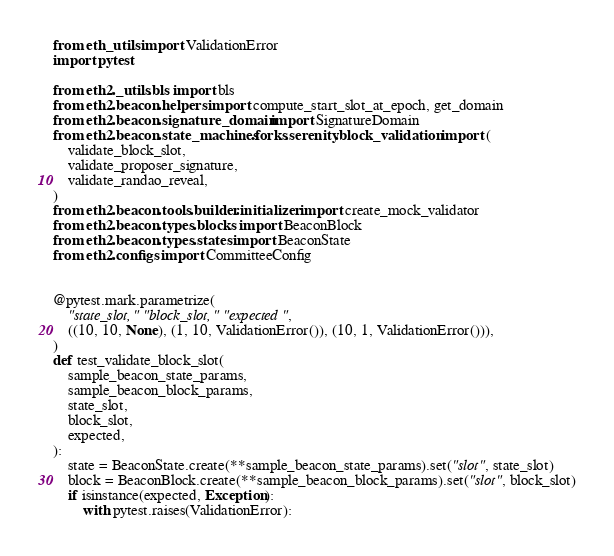<code> <loc_0><loc_0><loc_500><loc_500><_Python_>from eth_utils import ValidationError
import pytest

from eth2._utils.bls import bls
from eth2.beacon.helpers import compute_start_slot_at_epoch, get_domain
from eth2.beacon.signature_domain import SignatureDomain
from eth2.beacon.state_machines.forks.serenity.block_validation import (
    validate_block_slot,
    validate_proposer_signature,
    validate_randao_reveal,
)
from eth2.beacon.tools.builder.initializer import create_mock_validator
from eth2.beacon.types.blocks import BeaconBlock
from eth2.beacon.types.states import BeaconState
from eth2.configs import CommitteeConfig


@pytest.mark.parametrize(
    "state_slot," "block_slot," "expected",
    ((10, 10, None), (1, 10, ValidationError()), (10, 1, ValidationError())),
)
def test_validate_block_slot(
    sample_beacon_state_params,
    sample_beacon_block_params,
    state_slot,
    block_slot,
    expected,
):
    state = BeaconState.create(**sample_beacon_state_params).set("slot", state_slot)
    block = BeaconBlock.create(**sample_beacon_block_params).set("slot", block_slot)
    if isinstance(expected, Exception):
        with pytest.raises(ValidationError):</code> 